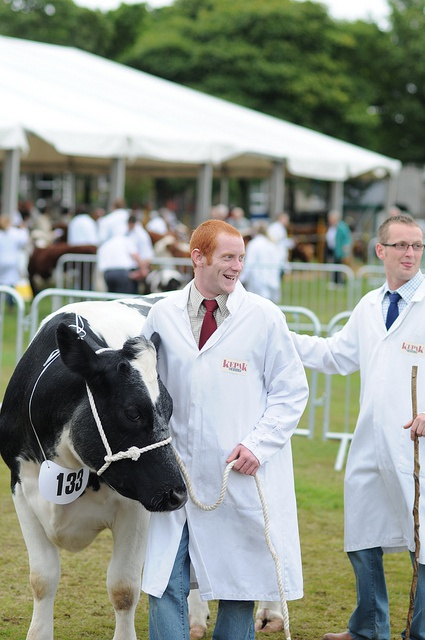Describe the objects in this image and their specific colors. I can see people in olive, lavender, lightgray, and darkgray tones, cow in olive, black, darkgray, gray, and lightgray tones, people in olive, lavender, darkgray, and lightgray tones, people in olive, lavender, darkgray, and lightgray tones, and people in olive, lavender, black, gray, and darkgray tones in this image. 